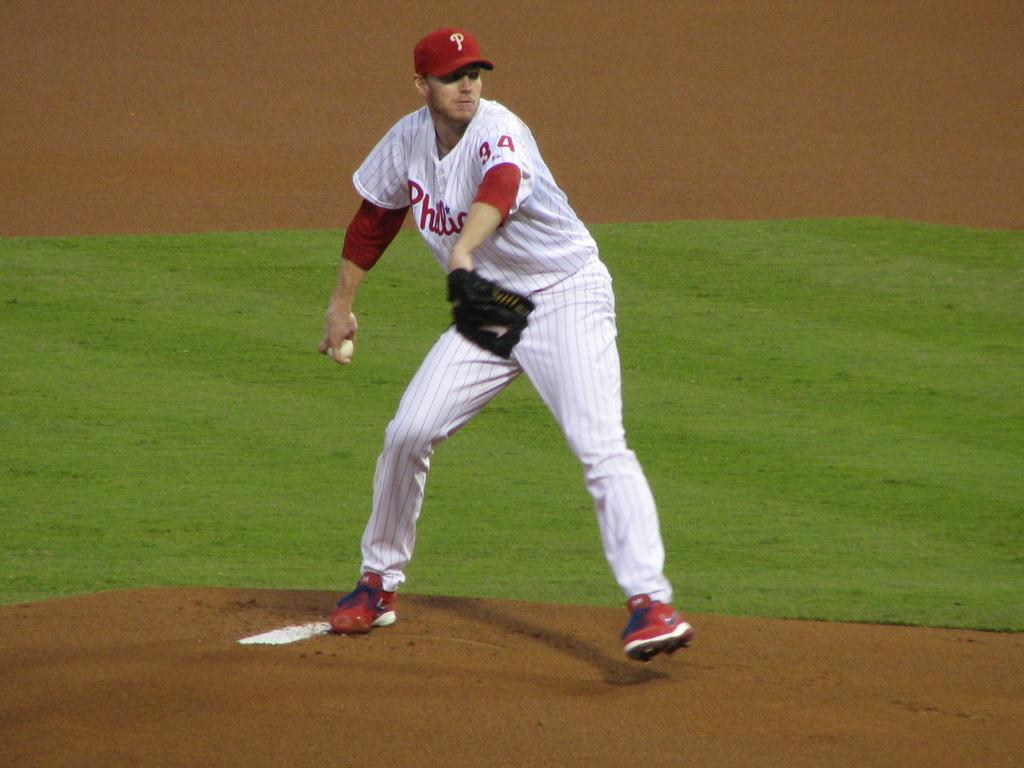<image>
Relay a brief, clear account of the picture shown. a philies baseball pitcher on the mound getting ready to throw the ball 